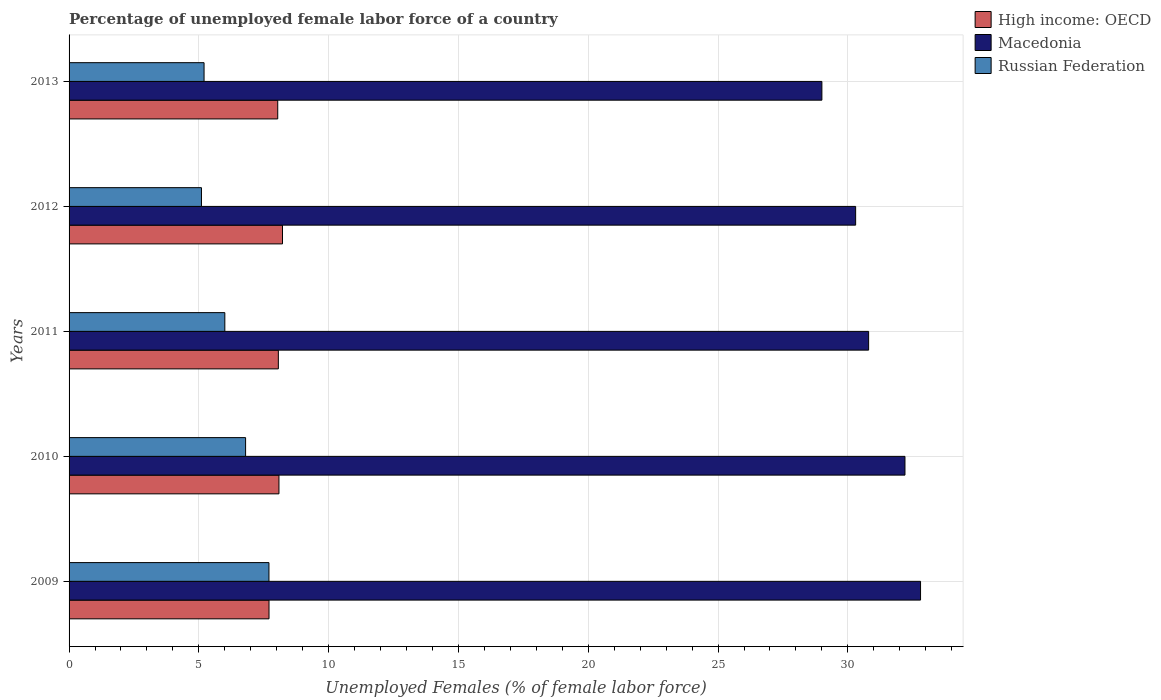How many different coloured bars are there?
Offer a terse response. 3. How many groups of bars are there?
Keep it short and to the point. 5. Are the number of bars per tick equal to the number of legend labels?
Your response must be concise. Yes. Are the number of bars on each tick of the Y-axis equal?
Offer a terse response. Yes. How many bars are there on the 5th tick from the bottom?
Your response must be concise. 3. What is the label of the 2nd group of bars from the top?
Your answer should be very brief. 2012. What is the percentage of unemployed female labor force in High income: OECD in 2013?
Ensure brevity in your answer.  8.04. Across all years, what is the maximum percentage of unemployed female labor force in Russian Federation?
Offer a very short reply. 7.7. Across all years, what is the minimum percentage of unemployed female labor force in High income: OECD?
Offer a terse response. 7.7. In which year was the percentage of unemployed female labor force in High income: OECD maximum?
Keep it short and to the point. 2012. In which year was the percentage of unemployed female labor force in High income: OECD minimum?
Provide a short and direct response. 2009. What is the total percentage of unemployed female labor force in High income: OECD in the graph?
Your answer should be very brief. 40.11. What is the difference between the percentage of unemployed female labor force in Macedonia in 2010 and that in 2013?
Offer a very short reply. 3.2. What is the difference between the percentage of unemployed female labor force in Russian Federation in 2009 and the percentage of unemployed female labor force in High income: OECD in 2013?
Ensure brevity in your answer.  -0.34. What is the average percentage of unemployed female labor force in High income: OECD per year?
Keep it short and to the point. 8.02. In the year 2013, what is the difference between the percentage of unemployed female labor force in Russian Federation and percentage of unemployed female labor force in High income: OECD?
Ensure brevity in your answer.  -2.84. What is the ratio of the percentage of unemployed female labor force in High income: OECD in 2011 to that in 2013?
Offer a terse response. 1. Is the percentage of unemployed female labor force in Macedonia in 2011 less than that in 2013?
Provide a short and direct response. No. What is the difference between the highest and the second highest percentage of unemployed female labor force in High income: OECD?
Offer a very short reply. 0.14. What is the difference between the highest and the lowest percentage of unemployed female labor force in High income: OECD?
Offer a very short reply. 0.52. In how many years, is the percentage of unemployed female labor force in High income: OECD greater than the average percentage of unemployed female labor force in High income: OECD taken over all years?
Provide a succinct answer. 4. What does the 1st bar from the top in 2010 represents?
Your answer should be compact. Russian Federation. What does the 3rd bar from the bottom in 2011 represents?
Provide a short and direct response. Russian Federation. Is it the case that in every year, the sum of the percentage of unemployed female labor force in Macedonia and percentage of unemployed female labor force in Russian Federation is greater than the percentage of unemployed female labor force in High income: OECD?
Your answer should be very brief. Yes. How many bars are there?
Offer a terse response. 15. What is the difference between two consecutive major ticks on the X-axis?
Keep it short and to the point. 5. Are the values on the major ticks of X-axis written in scientific E-notation?
Your answer should be very brief. No. How are the legend labels stacked?
Offer a very short reply. Vertical. What is the title of the graph?
Make the answer very short. Percentage of unemployed female labor force of a country. Does "United Arab Emirates" appear as one of the legend labels in the graph?
Your answer should be compact. No. What is the label or title of the X-axis?
Provide a short and direct response. Unemployed Females (% of female labor force). What is the Unemployed Females (% of female labor force) in High income: OECD in 2009?
Make the answer very short. 7.7. What is the Unemployed Females (% of female labor force) of Macedonia in 2009?
Keep it short and to the point. 32.8. What is the Unemployed Females (% of female labor force) in Russian Federation in 2009?
Ensure brevity in your answer.  7.7. What is the Unemployed Females (% of female labor force) of High income: OECD in 2010?
Provide a short and direct response. 8.09. What is the Unemployed Females (% of female labor force) of Macedonia in 2010?
Provide a short and direct response. 32.2. What is the Unemployed Females (% of female labor force) in Russian Federation in 2010?
Offer a very short reply. 6.8. What is the Unemployed Females (% of female labor force) in High income: OECD in 2011?
Your answer should be compact. 8.06. What is the Unemployed Females (% of female labor force) in Macedonia in 2011?
Your response must be concise. 30.8. What is the Unemployed Females (% of female labor force) of High income: OECD in 2012?
Your response must be concise. 8.22. What is the Unemployed Females (% of female labor force) of Macedonia in 2012?
Provide a short and direct response. 30.3. What is the Unemployed Females (% of female labor force) in Russian Federation in 2012?
Your answer should be very brief. 5.1. What is the Unemployed Females (% of female labor force) of High income: OECD in 2013?
Your response must be concise. 8.04. What is the Unemployed Females (% of female labor force) in Macedonia in 2013?
Your answer should be compact. 29. What is the Unemployed Females (% of female labor force) in Russian Federation in 2013?
Provide a short and direct response. 5.2. Across all years, what is the maximum Unemployed Females (% of female labor force) in High income: OECD?
Your answer should be compact. 8.22. Across all years, what is the maximum Unemployed Females (% of female labor force) in Macedonia?
Offer a terse response. 32.8. Across all years, what is the maximum Unemployed Females (% of female labor force) of Russian Federation?
Provide a short and direct response. 7.7. Across all years, what is the minimum Unemployed Females (% of female labor force) in High income: OECD?
Offer a very short reply. 7.7. Across all years, what is the minimum Unemployed Females (% of female labor force) of Macedonia?
Give a very brief answer. 29. Across all years, what is the minimum Unemployed Females (% of female labor force) of Russian Federation?
Provide a short and direct response. 5.1. What is the total Unemployed Females (% of female labor force) of High income: OECD in the graph?
Offer a terse response. 40.11. What is the total Unemployed Females (% of female labor force) in Macedonia in the graph?
Provide a succinct answer. 155.1. What is the total Unemployed Females (% of female labor force) of Russian Federation in the graph?
Offer a very short reply. 30.8. What is the difference between the Unemployed Females (% of female labor force) of High income: OECD in 2009 and that in 2010?
Provide a succinct answer. -0.38. What is the difference between the Unemployed Females (% of female labor force) in High income: OECD in 2009 and that in 2011?
Offer a very short reply. -0.36. What is the difference between the Unemployed Females (% of female labor force) of Macedonia in 2009 and that in 2011?
Offer a terse response. 2. What is the difference between the Unemployed Females (% of female labor force) of High income: OECD in 2009 and that in 2012?
Keep it short and to the point. -0.52. What is the difference between the Unemployed Females (% of female labor force) of Macedonia in 2009 and that in 2012?
Provide a succinct answer. 2.5. What is the difference between the Unemployed Females (% of female labor force) of Russian Federation in 2009 and that in 2012?
Make the answer very short. 2.6. What is the difference between the Unemployed Females (% of female labor force) in High income: OECD in 2009 and that in 2013?
Offer a terse response. -0.34. What is the difference between the Unemployed Females (% of female labor force) of Macedonia in 2009 and that in 2013?
Ensure brevity in your answer.  3.8. What is the difference between the Unemployed Females (% of female labor force) of Russian Federation in 2009 and that in 2013?
Provide a short and direct response. 2.5. What is the difference between the Unemployed Females (% of female labor force) in High income: OECD in 2010 and that in 2011?
Ensure brevity in your answer.  0.02. What is the difference between the Unemployed Females (% of female labor force) of Russian Federation in 2010 and that in 2011?
Make the answer very short. 0.8. What is the difference between the Unemployed Females (% of female labor force) in High income: OECD in 2010 and that in 2012?
Offer a very short reply. -0.14. What is the difference between the Unemployed Females (% of female labor force) of Macedonia in 2010 and that in 2012?
Provide a short and direct response. 1.9. What is the difference between the Unemployed Females (% of female labor force) of Russian Federation in 2010 and that in 2012?
Keep it short and to the point. 1.7. What is the difference between the Unemployed Females (% of female labor force) in High income: OECD in 2010 and that in 2013?
Your answer should be compact. 0.05. What is the difference between the Unemployed Females (% of female labor force) of Macedonia in 2010 and that in 2013?
Provide a short and direct response. 3.2. What is the difference between the Unemployed Females (% of female labor force) in Russian Federation in 2010 and that in 2013?
Provide a short and direct response. 1.6. What is the difference between the Unemployed Females (% of female labor force) of High income: OECD in 2011 and that in 2012?
Provide a short and direct response. -0.16. What is the difference between the Unemployed Females (% of female labor force) of Russian Federation in 2011 and that in 2012?
Ensure brevity in your answer.  0.9. What is the difference between the Unemployed Females (% of female labor force) in High income: OECD in 2011 and that in 2013?
Your answer should be very brief. 0.02. What is the difference between the Unemployed Females (% of female labor force) of High income: OECD in 2012 and that in 2013?
Provide a succinct answer. 0.18. What is the difference between the Unemployed Females (% of female labor force) of High income: OECD in 2009 and the Unemployed Females (% of female labor force) of Macedonia in 2010?
Ensure brevity in your answer.  -24.5. What is the difference between the Unemployed Females (% of female labor force) of High income: OECD in 2009 and the Unemployed Females (% of female labor force) of Russian Federation in 2010?
Make the answer very short. 0.9. What is the difference between the Unemployed Females (% of female labor force) in High income: OECD in 2009 and the Unemployed Females (% of female labor force) in Macedonia in 2011?
Keep it short and to the point. -23.1. What is the difference between the Unemployed Females (% of female labor force) of High income: OECD in 2009 and the Unemployed Females (% of female labor force) of Russian Federation in 2011?
Give a very brief answer. 1.7. What is the difference between the Unemployed Females (% of female labor force) in Macedonia in 2009 and the Unemployed Females (% of female labor force) in Russian Federation in 2011?
Offer a terse response. 26.8. What is the difference between the Unemployed Females (% of female labor force) in High income: OECD in 2009 and the Unemployed Females (% of female labor force) in Macedonia in 2012?
Provide a short and direct response. -22.6. What is the difference between the Unemployed Females (% of female labor force) in High income: OECD in 2009 and the Unemployed Females (% of female labor force) in Russian Federation in 2012?
Offer a terse response. 2.6. What is the difference between the Unemployed Females (% of female labor force) in Macedonia in 2009 and the Unemployed Females (% of female labor force) in Russian Federation in 2012?
Your response must be concise. 27.7. What is the difference between the Unemployed Females (% of female labor force) of High income: OECD in 2009 and the Unemployed Females (% of female labor force) of Macedonia in 2013?
Make the answer very short. -21.3. What is the difference between the Unemployed Females (% of female labor force) of High income: OECD in 2009 and the Unemployed Females (% of female labor force) of Russian Federation in 2013?
Your answer should be very brief. 2.5. What is the difference between the Unemployed Females (% of female labor force) in Macedonia in 2009 and the Unemployed Females (% of female labor force) in Russian Federation in 2013?
Ensure brevity in your answer.  27.6. What is the difference between the Unemployed Females (% of female labor force) in High income: OECD in 2010 and the Unemployed Females (% of female labor force) in Macedonia in 2011?
Your answer should be compact. -22.71. What is the difference between the Unemployed Females (% of female labor force) of High income: OECD in 2010 and the Unemployed Females (% of female labor force) of Russian Federation in 2011?
Your response must be concise. 2.09. What is the difference between the Unemployed Females (% of female labor force) in Macedonia in 2010 and the Unemployed Females (% of female labor force) in Russian Federation in 2011?
Offer a terse response. 26.2. What is the difference between the Unemployed Females (% of female labor force) of High income: OECD in 2010 and the Unemployed Females (% of female labor force) of Macedonia in 2012?
Provide a succinct answer. -22.21. What is the difference between the Unemployed Females (% of female labor force) of High income: OECD in 2010 and the Unemployed Females (% of female labor force) of Russian Federation in 2012?
Keep it short and to the point. 2.99. What is the difference between the Unemployed Females (% of female labor force) in Macedonia in 2010 and the Unemployed Females (% of female labor force) in Russian Federation in 2012?
Your answer should be compact. 27.1. What is the difference between the Unemployed Females (% of female labor force) of High income: OECD in 2010 and the Unemployed Females (% of female labor force) of Macedonia in 2013?
Give a very brief answer. -20.91. What is the difference between the Unemployed Females (% of female labor force) of High income: OECD in 2010 and the Unemployed Females (% of female labor force) of Russian Federation in 2013?
Your answer should be very brief. 2.89. What is the difference between the Unemployed Females (% of female labor force) in Macedonia in 2010 and the Unemployed Females (% of female labor force) in Russian Federation in 2013?
Provide a short and direct response. 27. What is the difference between the Unemployed Females (% of female labor force) of High income: OECD in 2011 and the Unemployed Females (% of female labor force) of Macedonia in 2012?
Provide a succinct answer. -22.24. What is the difference between the Unemployed Females (% of female labor force) of High income: OECD in 2011 and the Unemployed Females (% of female labor force) of Russian Federation in 2012?
Your response must be concise. 2.96. What is the difference between the Unemployed Females (% of female labor force) of Macedonia in 2011 and the Unemployed Females (% of female labor force) of Russian Federation in 2012?
Give a very brief answer. 25.7. What is the difference between the Unemployed Females (% of female labor force) in High income: OECD in 2011 and the Unemployed Females (% of female labor force) in Macedonia in 2013?
Ensure brevity in your answer.  -20.94. What is the difference between the Unemployed Females (% of female labor force) in High income: OECD in 2011 and the Unemployed Females (% of female labor force) in Russian Federation in 2013?
Your response must be concise. 2.86. What is the difference between the Unemployed Females (% of female labor force) of Macedonia in 2011 and the Unemployed Females (% of female labor force) of Russian Federation in 2013?
Provide a succinct answer. 25.6. What is the difference between the Unemployed Females (% of female labor force) of High income: OECD in 2012 and the Unemployed Females (% of female labor force) of Macedonia in 2013?
Offer a very short reply. -20.78. What is the difference between the Unemployed Females (% of female labor force) in High income: OECD in 2012 and the Unemployed Females (% of female labor force) in Russian Federation in 2013?
Your response must be concise. 3.02. What is the difference between the Unemployed Females (% of female labor force) of Macedonia in 2012 and the Unemployed Females (% of female labor force) of Russian Federation in 2013?
Your response must be concise. 25.1. What is the average Unemployed Females (% of female labor force) in High income: OECD per year?
Your answer should be very brief. 8.02. What is the average Unemployed Females (% of female labor force) of Macedonia per year?
Make the answer very short. 31.02. What is the average Unemployed Females (% of female labor force) in Russian Federation per year?
Provide a succinct answer. 6.16. In the year 2009, what is the difference between the Unemployed Females (% of female labor force) of High income: OECD and Unemployed Females (% of female labor force) of Macedonia?
Keep it short and to the point. -25.1. In the year 2009, what is the difference between the Unemployed Females (% of female labor force) of High income: OECD and Unemployed Females (% of female labor force) of Russian Federation?
Your answer should be very brief. 0. In the year 2009, what is the difference between the Unemployed Females (% of female labor force) in Macedonia and Unemployed Females (% of female labor force) in Russian Federation?
Your answer should be very brief. 25.1. In the year 2010, what is the difference between the Unemployed Females (% of female labor force) in High income: OECD and Unemployed Females (% of female labor force) in Macedonia?
Provide a short and direct response. -24.11. In the year 2010, what is the difference between the Unemployed Females (% of female labor force) of High income: OECD and Unemployed Females (% of female labor force) of Russian Federation?
Ensure brevity in your answer.  1.29. In the year 2010, what is the difference between the Unemployed Females (% of female labor force) in Macedonia and Unemployed Females (% of female labor force) in Russian Federation?
Offer a very short reply. 25.4. In the year 2011, what is the difference between the Unemployed Females (% of female labor force) in High income: OECD and Unemployed Females (% of female labor force) in Macedonia?
Provide a short and direct response. -22.74. In the year 2011, what is the difference between the Unemployed Females (% of female labor force) in High income: OECD and Unemployed Females (% of female labor force) in Russian Federation?
Make the answer very short. 2.06. In the year 2011, what is the difference between the Unemployed Females (% of female labor force) in Macedonia and Unemployed Females (% of female labor force) in Russian Federation?
Provide a succinct answer. 24.8. In the year 2012, what is the difference between the Unemployed Females (% of female labor force) in High income: OECD and Unemployed Females (% of female labor force) in Macedonia?
Offer a terse response. -22.08. In the year 2012, what is the difference between the Unemployed Females (% of female labor force) of High income: OECD and Unemployed Females (% of female labor force) of Russian Federation?
Your answer should be very brief. 3.12. In the year 2012, what is the difference between the Unemployed Females (% of female labor force) of Macedonia and Unemployed Females (% of female labor force) of Russian Federation?
Offer a terse response. 25.2. In the year 2013, what is the difference between the Unemployed Females (% of female labor force) of High income: OECD and Unemployed Females (% of female labor force) of Macedonia?
Give a very brief answer. -20.96. In the year 2013, what is the difference between the Unemployed Females (% of female labor force) of High income: OECD and Unemployed Females (% of female labor force) of Russian Federation?
Offer a terse response. 2.84. In the year 2013, what is the difference between the Unemployed Females (% of female labor force) of Macedonia and Unemployed Females (% of female labor force) of Russian Federation?
Offer a very short reply. 23.8. What is the ratio of the Unemployed Females (% of female labor force) of High income: OECD in 2009 to that in 2010?
Ensure brevity in your answer.  0.95. What is the ratio of the Unemployed Females (% of female labor force) of Macedonia in 2009 to that in 2010?
Offer a very short reply. 1.02. What is the ratio of the Unemployed Females (% of female labor force) in Russian Federation in 2009 to that in 2010?
Your answer should be compact. 1.13. What is the ratio of the Unemployed Females (% of female labor force) in High income: OECD in 2009 to that in 2011?
Ensure brevity in your answer.  0.96. What is the ratio of the Unemployed Females (% of female labor force) in Macedonia in 2009 to that in 2011?
Your answer should be very brief. 1.06. What is the ratio of the Unemployed Females (% of female labor force) of Russian Federation in 2009 to that in 2011?
Ensure brevity in your answer.  1.28. What is the ratio of the Unemployed Females (% of female labor force) of High income: OECD in 2009 to that in 2012?
Make the answer very short. 0.94. What is the ratio of the Unemployed Females (% of female labor force) of Macedonia in 2009 to that in 2012?
Your response must be concise. 1.08. What is the ratio of the Unemployed Females (% of female labor force) of Russian Federation in 2009 to that in 2012?
Provide a short and direct response. 1.51. What is the ratio of the Unemployed Females (% of female labor force) in High income: OECD in 2009 to that in 2013?
Make the answer very short. 0.96. What is the ratio of the Unemployed Females (% of female labor force) in Macedonia in 2009 to that in 2013?
Ensure brevity in your answer.  1.13. What is the ratio of the Unemployed Females (% of female labor force) of Russian Federation in 2009 to that in 2013?
Your response must be concise. 1.48. What is the ratio of the Unemployed Females (% of female labor force) of High income: OECD in 2010 to that in 2011?
Your answer should be very brief. 1. What is the ratio of the Unemployed Females (% of female labor force) of Macedonia in 2010 to that in 2011?
Ensure brevity in your answer.  1.05. What is the ratio of the Unemployed Females (% of female labor force) of Russian Federation in 2010 to that in 2011?
Your answer should be very brief. 1.13. What is the ratio of the Unemployed Females (% of female labor force) of High income: OECD in 2010 to that in 2012?
Your answer should be compact. 0.98. What is the ratio of the Unemployed Females (% of female labor force) of Macedonia in 2010 to that in 2012?
Keep it short and to the point. 1.06. What is the ratio of the Unemployed Females (% of female labor force) in Russian Federation in 2010 to that in 2012?
Give a very brief answer. 1.33. What is the ratio of the Unemployed Females (% of female labor force) in High income: OECD in 2010 to that in 2013?
Give a very brief answer. 1.01. What is the ratio of the Unemployed Females (% of female labor force) of Macedonia in 2010 to that in 2013?
Keep it short and to the point. 1.11. What is the ratio of the Unemployed Females (% of female labor force) in Russian Federation in 2010 to that in 2013?
Offer a very short reply. 1.31. What is the ratio of the Unemployed Females (% of female labor force) in High income: OECD in 2011 to that in 2012?
Provide a short and direct response. 0.98. What is the ratio of the Unemployed Females (% of female labor force) of Macedonia in 2011 to that in 2012?
Provide a succinct answer. 1.02. What is the ratio of the Unemployed Females (% of female labor force) in Russian Federation in 2011 to that in 2012?
Keep it short and to the point. 1.18. What is the ratio of the Unemployed Females (% of female labor force) of Macedonia in 2011 to that in 2013?
Provide a short and direct response. 1.06. What is the ratio of the Unemployed Females (% of female labor force) of Russian Federation in 2011 to that in 2013?
Give a very brief answer. 1.15. What is the ratio of the Unemployed Females (% of female labor force) of High income: OECD in 2012 to that in 2013?
Your response must be concise. 1.02. What is the ratio of the Unemployed Females (% of female labor force) of Macedonia in 2012 to that in 2013?
Offer a terse response. 1.04. What is the ratio of the Unemployed Females (% of female labor force) in Russian Federation in 2012 to that in 2013?
Give a very brief answer. 0.98. What is the difference between the highest and the second highest Unemployed Females (% of female labor force) of High income: OECD?
Your answer should be compact. 0.14. What is the difference between the highest and the second highest Unemployed Females (% of female labor force) of Macedonia?
Offer a terse response. 0.6. What is the difference between the highest and the second highest Unemployed Females (% of female labor force) in Russian Federation?
Provide a short and direct response. 0.9. What is the difference between the highest and the lowest Unemployed Females (% of female labor force) of High income: OECD?
Offer a very short reply. 0.52. 